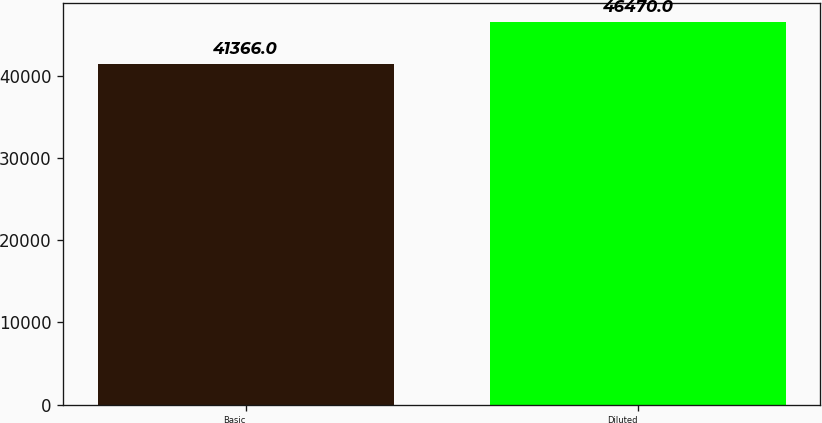<chart> <loc_0><loc_0><loc_500><loc_500><bar_chart><fcel>Basic<fcel>Diluted<nl><fcel>41366<fcel>46470<nl></chart> 